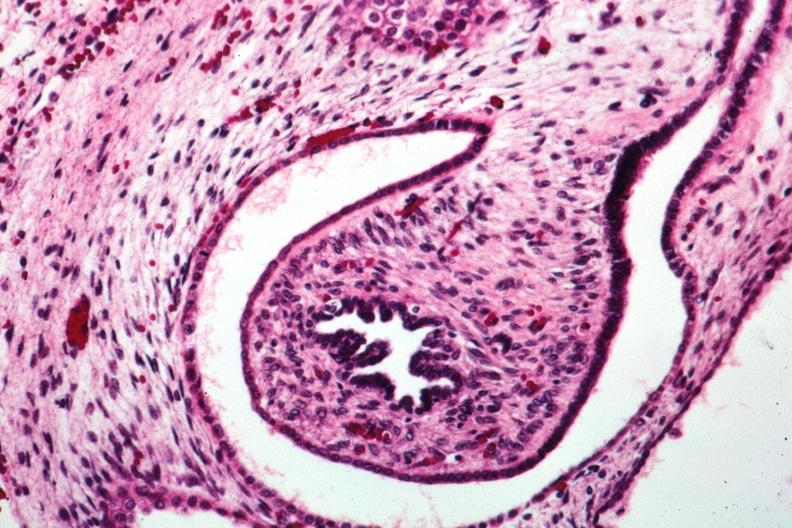what is present?
Answer the question using a single word or phrase. Polycystic disease infant 